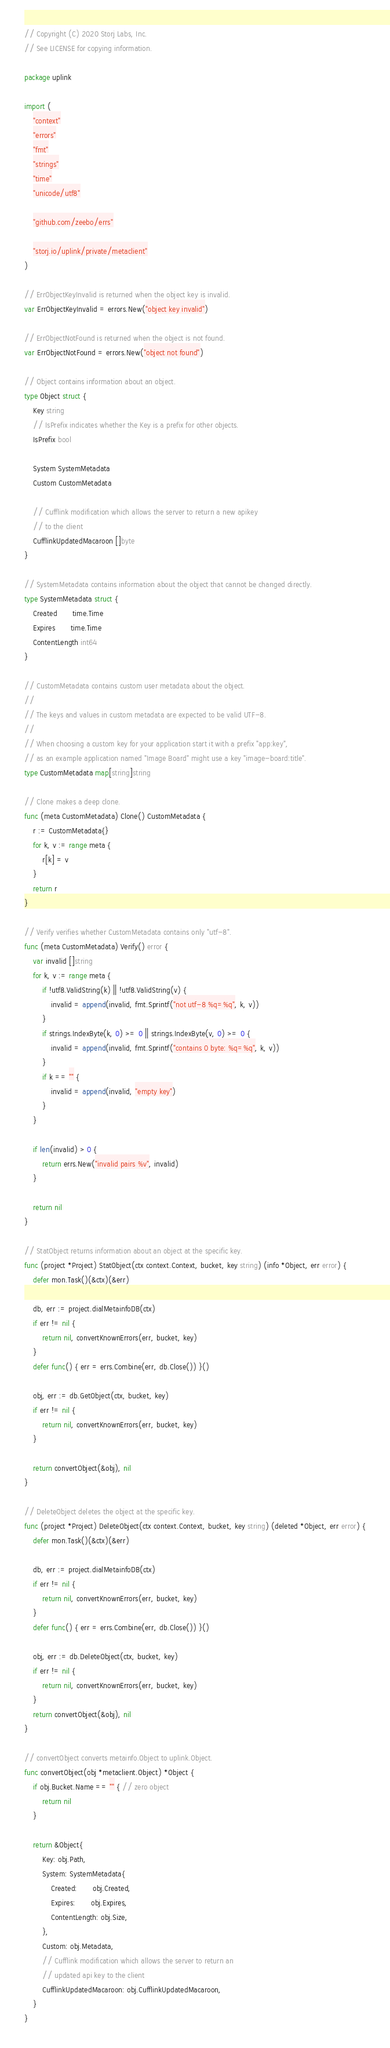<code> <loc_0><loc_0><loc_500><loc_500><_Go_>// Copyright (C) 2020 Storj Labs, Inc.
// See LICENSE for copying information.

package uplink

import (
	"context"
	"errors"
	"fmt"
	"strings"
	"time"
	"unicode/utf8"

	"github.com/zeebo/errs"

	"storj.io/uplink/private/metaclient"
)

// ErrObjectKeyInvalid is returned when the object key is invalid.
var ErrObjectKeyInvalid = errors.New("object key invalid")

// ErrObjectNotFound is returned when the object is not found.
var ErrObjectNotFound = errors.New("object not found")

// Object contains information about an object.
type Object struct {
	Key string
	// IsPrefix indicates whether the Key is a prefix for other objects.
	IsPrefix bool

	System SystemMetadata
	Custom CustomMetadata

	// Cufflink modification which allows the server to return a new apikey
	// to the client
	CufflinkUpdatedMacaroon []byte
}

// SystemMetadata contains information about the object that cannot be changed directly.
type SystemMetadata struct {
	Created       time.Time
	Expires       time.Time
	ContentLength int64
}

// CustomMetadata contains custom user metadata about the object.
//
// The keys and values in custom metadata are expected to be valid UTF-8.
//
// When choosing a custom key for your application start it with a prefix "app:key",
// as an example application named "Image Board" might use a key "image-board:title".
type CustomMetadata map[string]string

// Clone makes a deep clone.
func (meta CustomMetadata) Clone() CustomMetadata {
	r := CustomMetadata{}
	for k, v := range meta {
		r[k] = v
	}
	return r
}

// Verify verifies whether CustomMetadata contains only "utf-8".
func (meta CustomMetadata) Verify() error {
	var invalid []string
	for k, v := range meta {
		if !utf8.ValidString(k) || !utf8.ValidString(v) {
			invalid = append(invalid, fmt.Sprintf("not utf-8 %q=%q", k, v))
		}
		if strings.IndexByte(k, 0) >= 0 || strings.IndexByte(v, 0) >= 0 {
			invalid = append(invalid, fmt.Sprintf("contains 0 byte: %q=%q", k, v))
		}
		if k == "" {
			invalid = append(invalid, "empty key")
		}
	}

	if len(invalid) > 0 {
		return errs.New("invalid pairs %v", invalid)
	}

	return nil
}

// StatObject returns information about an object at the specific key.
func (project *Project) StatObject(ctx context.Context, bucket, key string) (info *Object, err error) {
	defer mon.Task()(&ctx)(&err)

	db, err := project.dialMetainfoDB(ctx)
	if err != nil {
		return nil, convertKnownErrors(err, bucket, key)
	}
	defer func() { err = errs.Combine(err, db.Close()) }()

	obj, err := db.GetObject(ctx, bucket, key)
	if err != nil {
		return nil, convertKnownErrors(err, bucket, key)
	}

	return convertObject(&obj), nil
}

// DeleteObject deletes the object at the specific key.
func (project *Project) DeleteObject(ctx context.Context, bucket, key string) (deleted *Object, err error) {
	defer mon.Task()(&ctx)(&err)

	db, err := project.dialMetainfoDB(ctx)
	if err != nil {
		return nil, convertKnownErrors(err, bucket, key)
	}
	defer func() { err = errs.Combine(err, db.Close()) }()

	obj, err := db.DeleteObject(ctx, bucket, key)
	if err != nil {
		return nil, convertKnownErrors(err, bucket, key)
	}
	return convertObject(&obj), nil
}

// convertObject converts metainfo.Object to uplink.Object.
func convertObject(obj *metaclient.Object) *Object {
	if obj.Bucket.Name == "" { // zero object
		return nil
	}

	return &Object{
		Key: obj.Path,
		System: SystemMetadata{
			Created:       obj.Created,
			Expires:       obj.Expires,
			ContentLength: obj.Size,
		},
		Custom: obj.Metadata,
		// Cufflink modification which allows the server to return an
		// updated api key to the client
		CufflinkUpdatedMacaroon: obj.CufflinkUpdatedMacaroon,
	}
}
</code> 